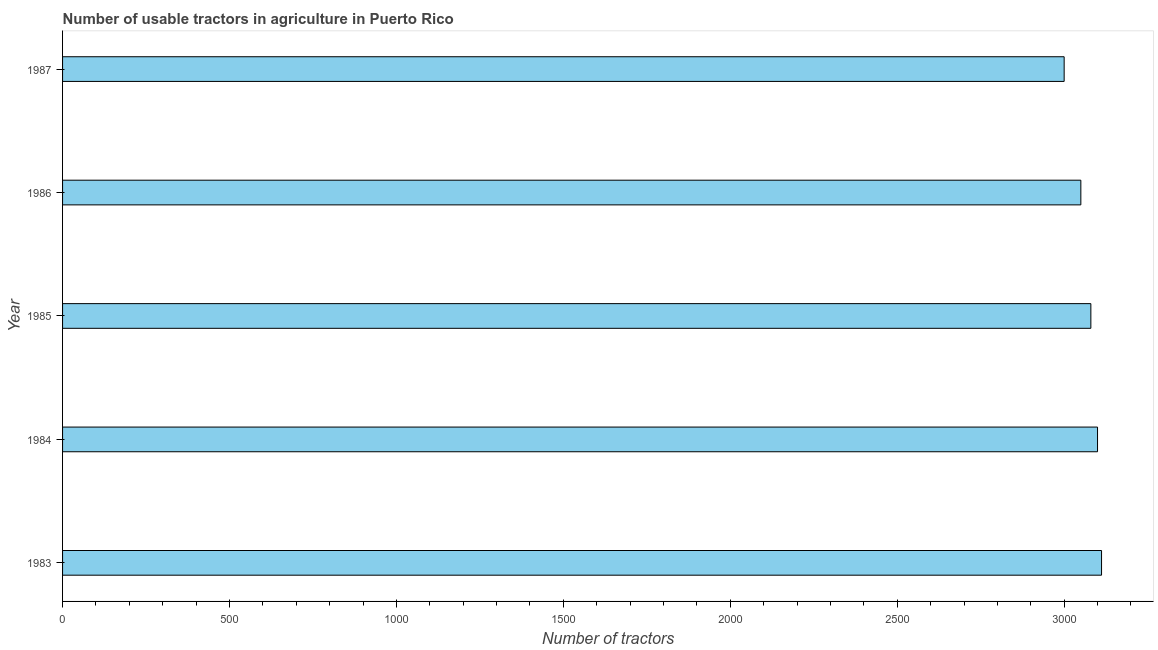Does the graph contain any zero values?
Keep it short and to the point. No. What is the title of the graph?
Your answer should be compact. Number of usable tractors in agriculture in Puerto Rico. What is the label or title of the X-axis?
Provide a succinct answer. Number of tractors. What is the number of tractors in 1985?
Make the answer very short. 3080. Across all years, what is the maximum number of tractors?
Your response must be concise. 3112. Across all years, what is the minimum number of tractors?
Keep it short and to the point. 3000. What is the sum of the number of tractors?
Ensure brevity in your answer.  1.53e+04. What is the average number of tractors per year?
Provide a short and direct response. 3068. What is the median number of tractors?
Provide a short and direct response. 3080. In how many years, is the number of tractors greater than 1700 ?
Give a very brief answer. 5. Do a majority of the years between 1986 and 1983 (inclusive) have number of tractors greater than 1600 ?
Offer a terse response. Yes. Is the number of tractors in 1983 less than that in 1987?
Keep it short and to the point. No. Is the difference between the number of tractors in 1986 and 1987 greater than the difference between any two years?
Your answer should be compact. No. Is the sum of the number of tractors in 1983 and 1987 greater than the maximum number of tractors across all years?
Your response must be concise. Yes. What is the difference between the highest and the lowest number of tractors?
Make the answer very short. 112. What is the difference between two consecutive major ticks on the X-axis?
Offer a terse response. 500. What is the Number of tractors in 1983?
Offer a very short reply. 3112. What is the Number of tractors of 1984?
Offer a terse response. 3100. What is the Number of tractors in 1985?
Keep it short and to the point. 3080. What is the Number of tractors in 1986?
Your answer should be compact. 3050. What is the Number of tractors of 1987?
Offer a terse response. 3000. What is the difference between the Number of tractors in 1983 and 1984?
Make the answer very short. 12. What is the difference between the Number of tractors in 1983 and 1985?
Your answer should be compact. 32. What is the difference between the Number of tractors in 1983 and 1986?
Your answer should be compact. 62. What is the difference between the Number of tractors in 1983 and 1987?
Provide a short and direct response. 112. What is the difference between the Number of tractors in 1984 and 1986?
Provide a short and direct response. 50. What is the difference between the Number of tractors in 1984 and 1987?
Keep it short and to the point. 100. What is the difference between the Number of tractors in 1985 and 1987?
Keep it short and to the point. 80. What is the ratio of the Number of tractors in 1983 to that in 1984?
Offer a very short reply. 1. What is the ratio of the Number of tractors in 1983 to that in 1986?
Offer a very short reply. 1.02. What is the ratio of the Number of tractors in 1983 to that in 1987?
Keep it short and to the point. 1.04. What is the ratio of the Number of tractors in 1984 to that in 1985?
Keep it short and to the point. 1.01. What is the ratio of the Number of tractors in 1984 to that in 1987?
Offer a very short reply. 1.03. What is the ratio of the Number of tractors in 1985 to that in 1986?
Provide a succinct answer. 1.01. What is the ratio of the Number of tractors in 1985 to that in 1987?
Your answer should be very brief. 1.03. 